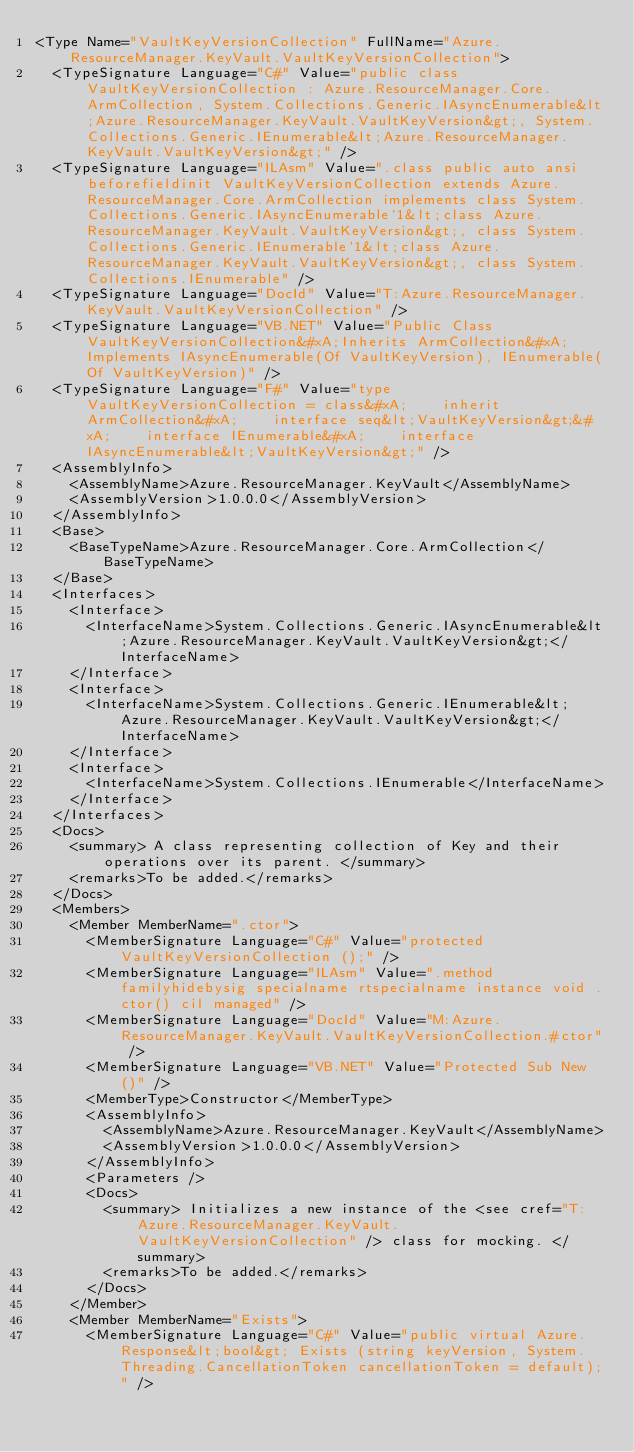<code> <loc_0><loc_0><loc_500><loc_500><_XML_><Type Name="VaultKeyVersionCollection" FullName="Azure.ResourceManager.KeyVault.VaultKeyVersionCollection">
  <TypeSignature Language="C#" Value="public class VaultKeyVersionCollection : Azure.ResourceManager.Core.ArmCollection, System.Collections.Generic.IAsyncEnumerable&lt;Azure.ResourceManager.KeyVault.VaultKeyVersion&gt;, System.Collections.Generic.IEnumerable&lt;Azure.ResourceManager.KeyVault.VaultKeyVersion&gt;" />
  <TypeSignature Language="ILAsm" Value=".class public auto ansi beforefieldinit VaultKeyVersionCollection extends Azure.ResourceManager.Core.ArmCollection implements class System.Collections.Generic.IAsyncEnumerable`1&lt;class Azure.ResourceManager.KeyVault.VaultKeyVersion&gt;, class System.Collections.Generic.IEnumerable`1&lt;class Azure.ResourceManager.KeyVault.VaultKeyVersion&gt;, class System.Collections.IEnumerable" />
  <TypeSignature Language="DocId" Value="T:Azure.ResourceManager.KeyVault.VaultKeyVersionCollection" />
  <TypeSignature Language="VB.NET" Value="Public Class VaultKeyVersionCollection&#xA;Inherits ArmCollection&#xA;Implements IAsyncEnumerable(Of VaultKeyVersion), IEnumerable(Of VaultKeyVersion)" />
  <TypeSignature Language="F#" Value="type VaultKeyVersionCollection = class&#xA;    inherit ArmCollection&#xA;    interface seq&lt;VaultKeyVersion&gt;&#xA;    interface IEnumerable&#xA;    interface IAsyncEnumerable&lt;VaultKeyVersion&gt;" />
  <AssemblyInfo>
    <AssemblyName>Azure.ResourceManager.KeyVault</AssemblyName>
    <AssemblyVersion>1.0.0.0</AssemblyVersion>
  </AssemblyInfo>
  <Base>
    <BaseTypeName>Azure.ResourceManager.Core.ArmCollection</BaseTypeName>
  </Base>
  <Interfaces>
    <Interface>
      <InterfaceName>System.Collections.Generic.IAsyncEnumerable&lt;Azure.ResourceManager.KeyVault.VaultKeyVersion&gt;</InterfaceName>
    </Interface>
    <Interface>
      <InterfaceName>System.Collections.Generic.IEnumerable&lt;Azure.ResourceManager.KeyVault.VaultKeyVersion&gt;</InterfaceName>
    </Interface>
    <Interface>
      <InterfaceName>System.Collections.IEnumerable</InterfaceName>
    </Interface>
  </Interfaces>
  <Docs>
    <summary> A class representing collection of Key and their operations over its parent. </summary>
    <remarks>To be added.</remarks>
  </Docs>
  <Members>
    <Member MemberName=".ctor">
      <MemberSignature Language="C#" Value="protected VaultKeyVersionCollection ();" />
      <MemberSignature Language="ILAsm" Value=".method familyhidebysig specialname rtspecialname instance void .ctor() cil managed" />
      <MemberSignature Language="DocId" Value="M:Azure.ResourceManager.KeyVault.VaultKeyVersionCollection.#ctor" />
      <MemberSignature Language="VB.NET" Value="Protected Sub New ()" />
      <MemberType>Constructor</MemberType>
      <AssemblyInfo>
        <AssemblyName>Azure.ResourceManager.KeyVault</AssemblyName>
        <AssemblyVersion>1.0.0.0</AssemblyVersion>
      </AssemblyInfo>
      <Parameters />
      <Docs>
        <summary> Initializes a new instance of the <see cref="T:Azure.ResourceManager.KeyVault.VaultKeyVersionCollection" /> class for mocking. </summary>
        <remarks>To be added.</remarks>
      </Docs>
    </Member>
    <Member MemberName="Exists">
      <MemberSignature Language="C#" Value="public virtual Azure.Response&lt;bool&gt; Exists (string keyVersion, System.Threading.CancellationToken cancellationToken = default);" /></code> 